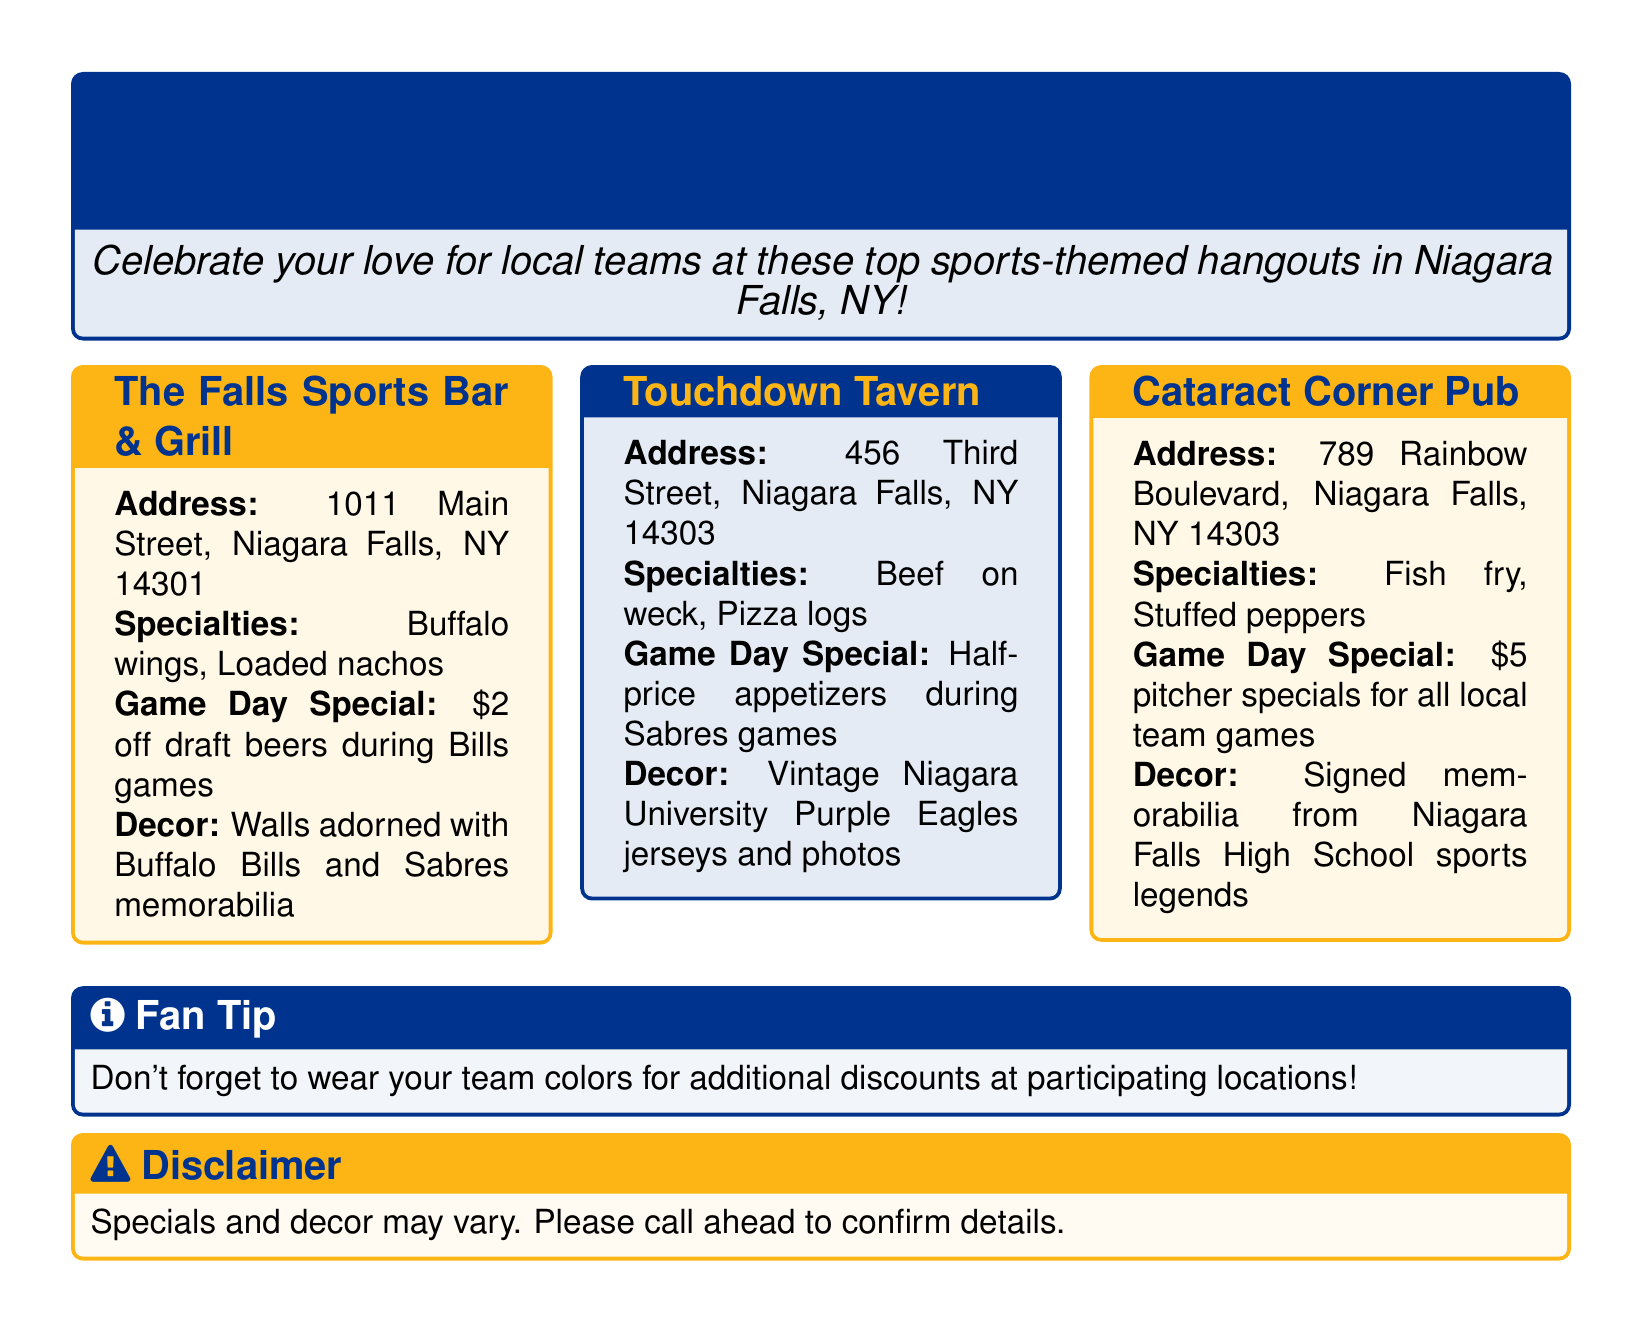What is the address of The Falls Sports Bar & Grill? The address of The Falls Sports Bar & Grill is provided in the document as 1011 Main Street, Niagara Falls, NY 14301.
Answer: 1011 Main Street, Niagara Falls, NY 14301 What is the game day special at Touchdown Tavern? The game day special at Touchdown Tavern is stated as half-price appetizers during Sabres games.
Answer: Half-price appetizers during Sabres games What are the specialties at Cataract Corner Pub? The document lists the specialties at Cataract Corner Pub as fish fry and stuffed peppers.
Answer: Fish fry, stuffed peppers Which sports team is featured in the decor at The Falls Sports Bar & Grill? The decor at The Falls Sports Bar & Grill includes memorabilia from the Buffalo Bills and Sabres.
Answer: Buffalo Bills and Sabres How much is the pitcher special at Cataract Corner Pub? The document specifies that the pitcher special at Cataract Corner Pub is $5 for all local team games.
Answer: $5 